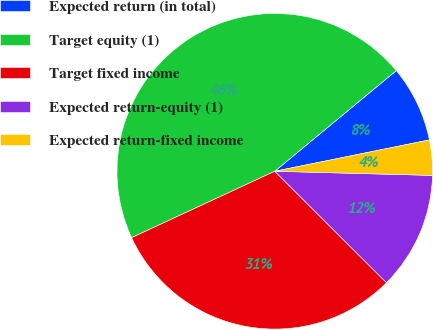Convert chart to OTSL. <chart><loc_0><loc_0><loc_500><loc_500><pie_chart><fcel>Expected return (in total)<fcel>Target equity (1)<fcel>Target fixed income<fcel>Expected return-equity (1)<fcel>Expected return-fixed income<nl><fcel>7.83%<fcel>45.91%<fcel>30.61%<fcel>12.06%<fcel>3.6%<nl></chart> 